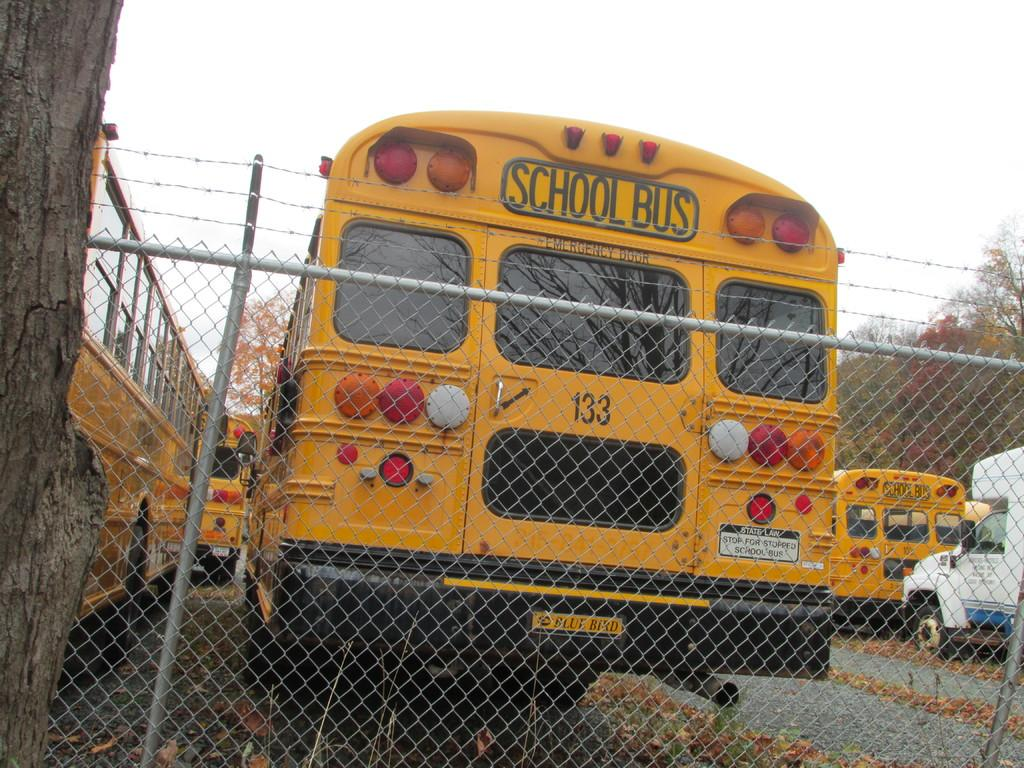<image>
Offer a succinct explanation of the picture presented. A school bus has a number 133 on its back door. 